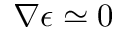<formula> <loc_0><loc_0><loc_500><loc_500>\nabla \epsilon \simeq 0</formula> 